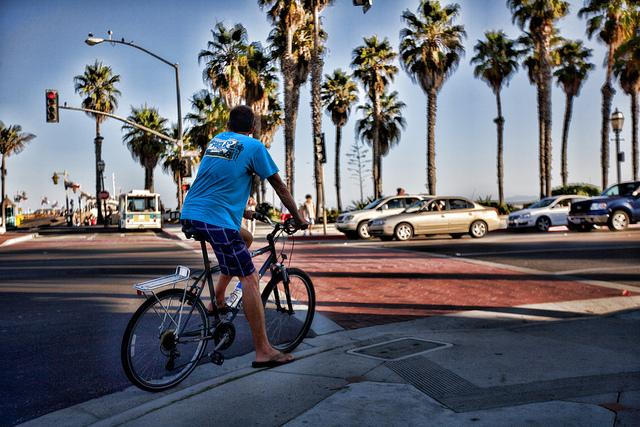What kind of transportation is shown? Please explain your reasoning. road. The transportation shown is a road where cars, bikes, and buses travel. 